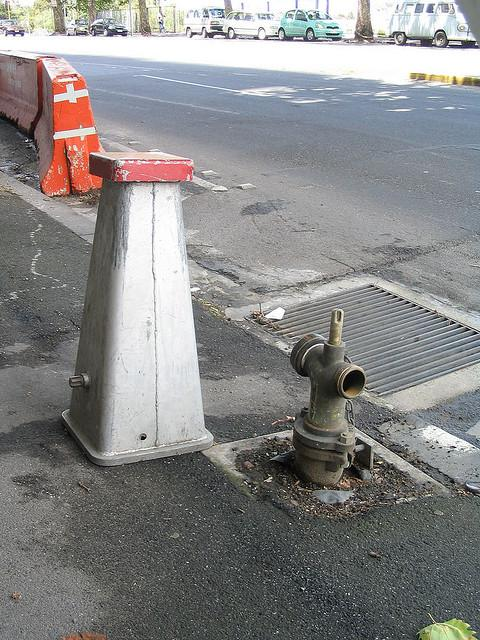What is on the floor?

Choices:
A) eggs
B) cat
C) grate
D) ketchup grate 